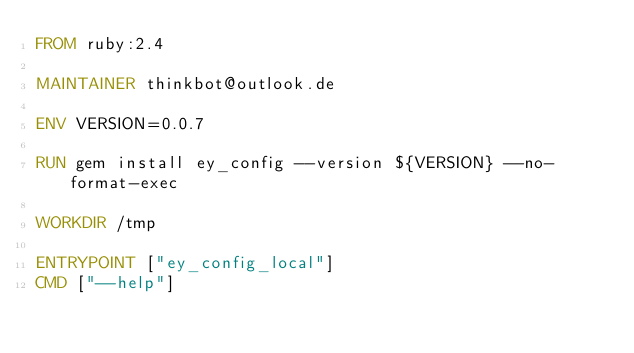Convert code to text. <code><loc_0><loc_0><loc_500><loc_500><_Dockerfile_>FROM ruby:2.4

MAINTAINER thinkbot@outlook.de

ENV VERSION=0.0.7

RUN gem install ey_config --version ${VERSION} --no-format-exec

WORKDIR /tmp

ENTRYPOINT ["ey_config_local"]
CMD ["--help"]
</code> 